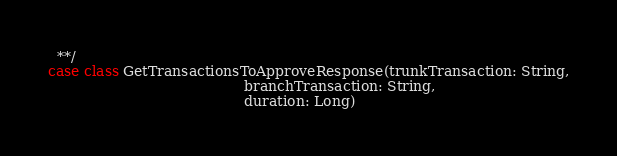Convert code to text. <code><loc_0><loc_0><loc_500><loc_500><_Scala_>  **/
case class GetTransactionsToApproveResponse(trunkTransaction: String,
                                            branchTransaction: String,
                                            duration: Long)
</code> 